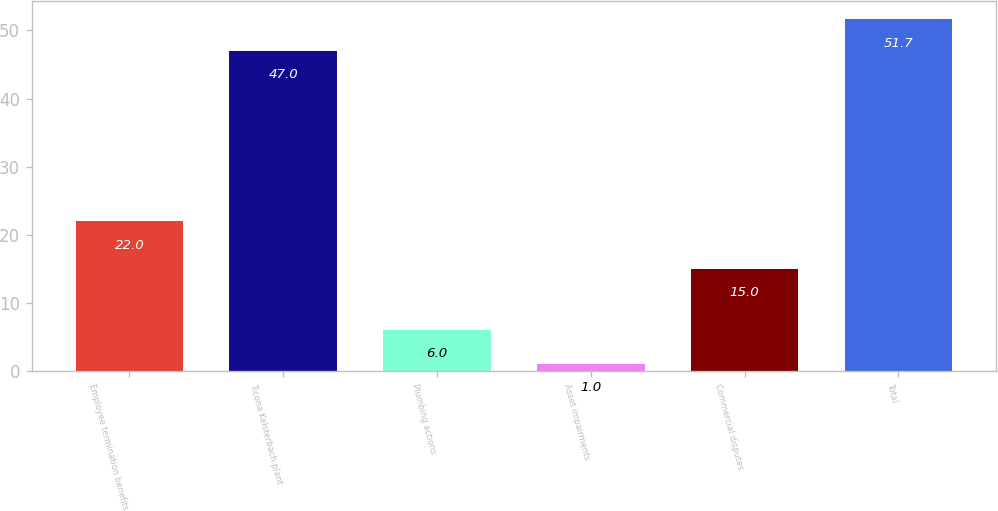Convert chart to OTSL. <chart><loc_0><loc_0><loc_500><loc_500><bar_chart><fcel>Employee termination benefits<fcel>Ticona Kelsterbach plant<fcel>Plumbing actions<fcel>Asset impairments<fcel>Commercial disputes<fcel>Total<nl><fcel>22<fcel>47<fcel>6<fcel>1<fcel>15<fcel>51.7<nl></chart> 